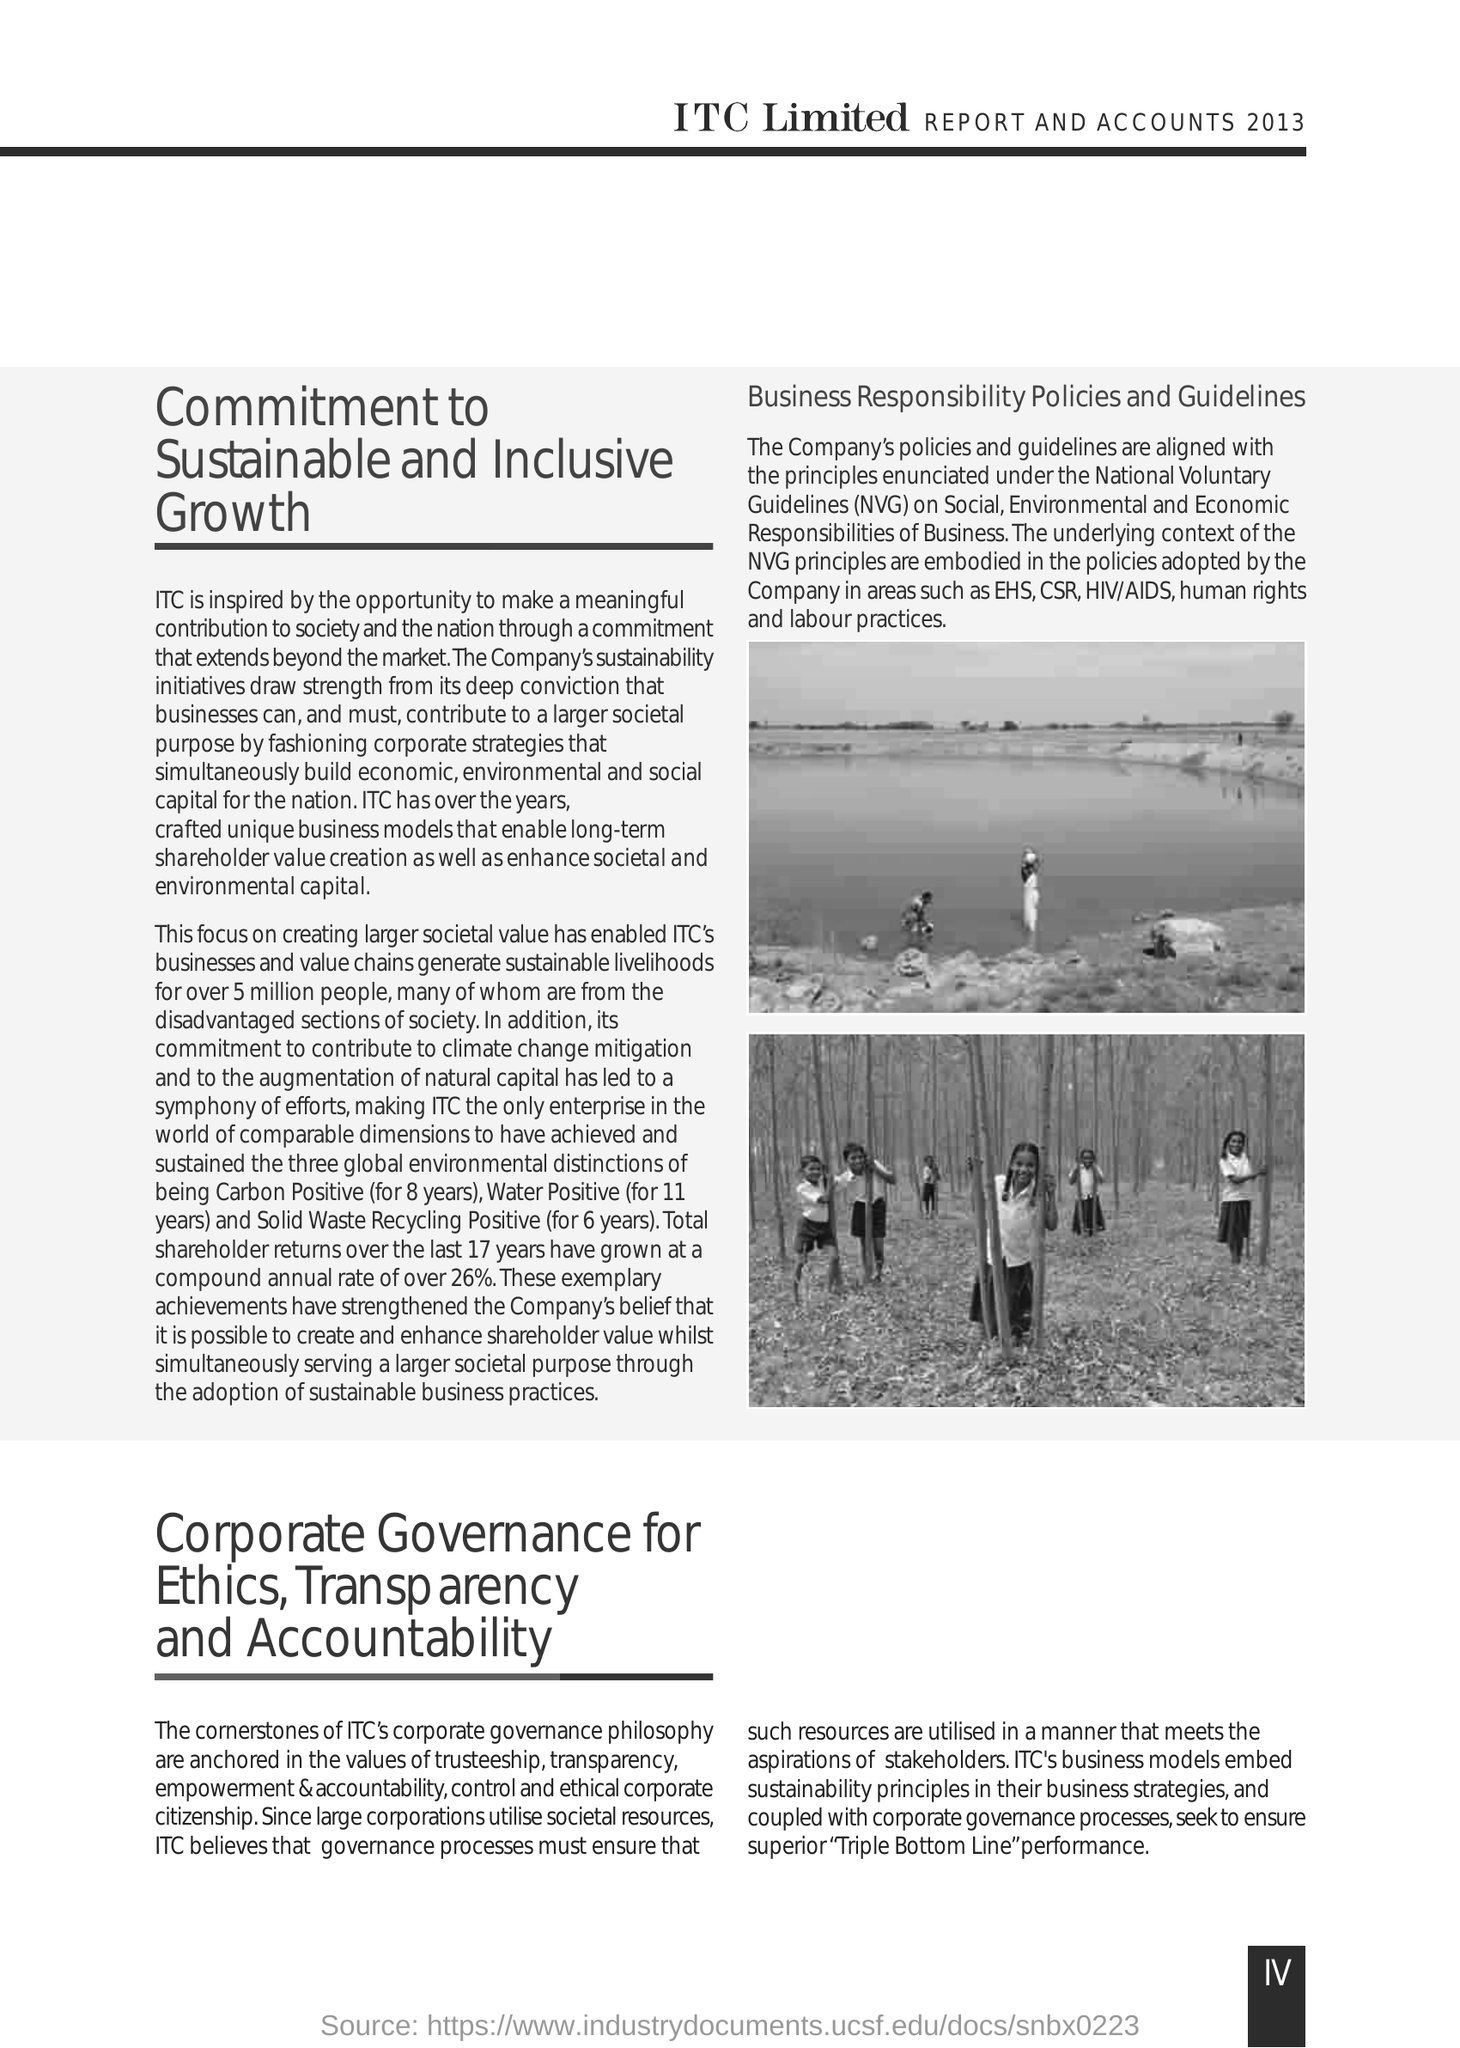What is the Fullform of NVG ?
Provide a short and direct response. National Voluntary Guidelines. 